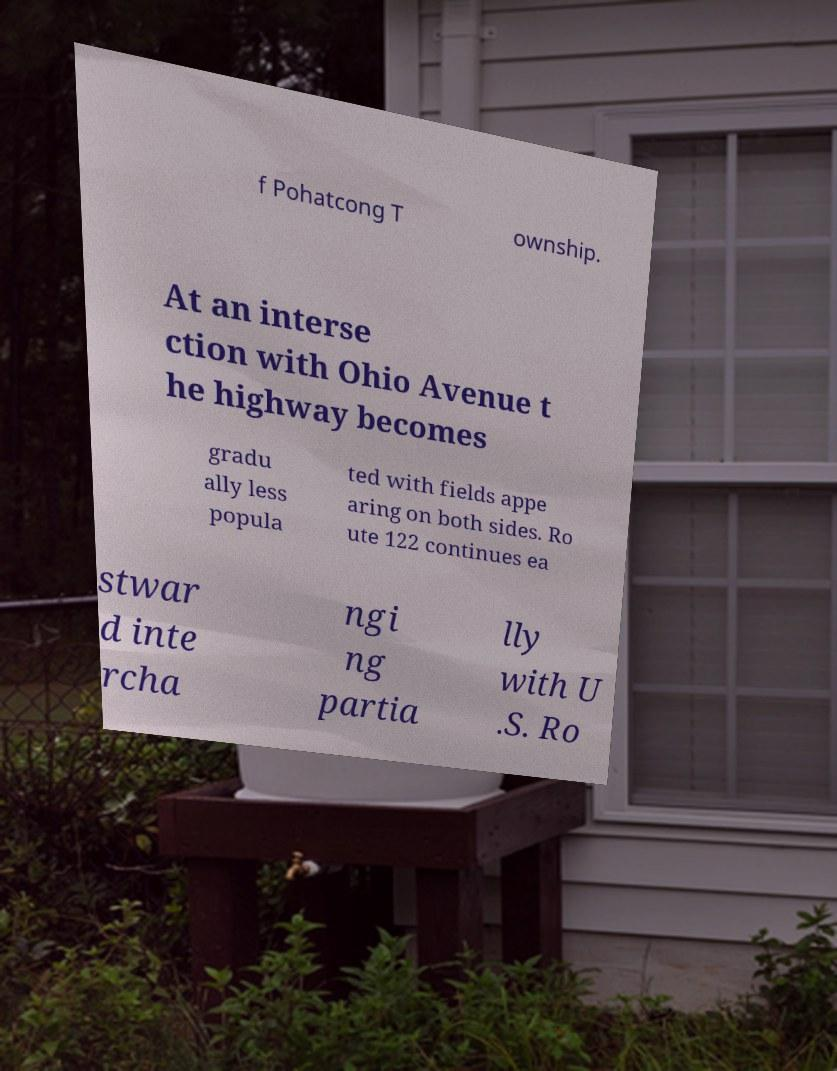I need the written content from this picture converted into text. Can you do that? f Pohatcong T ownship. At an interse ction with Ohio Avenue t he highway becomes gradu ally less popula ted with fields appe aring on both sides. Ro ute 122 continues ea stwar d inte rcha ngi ng partia lly with U .S. Ro 